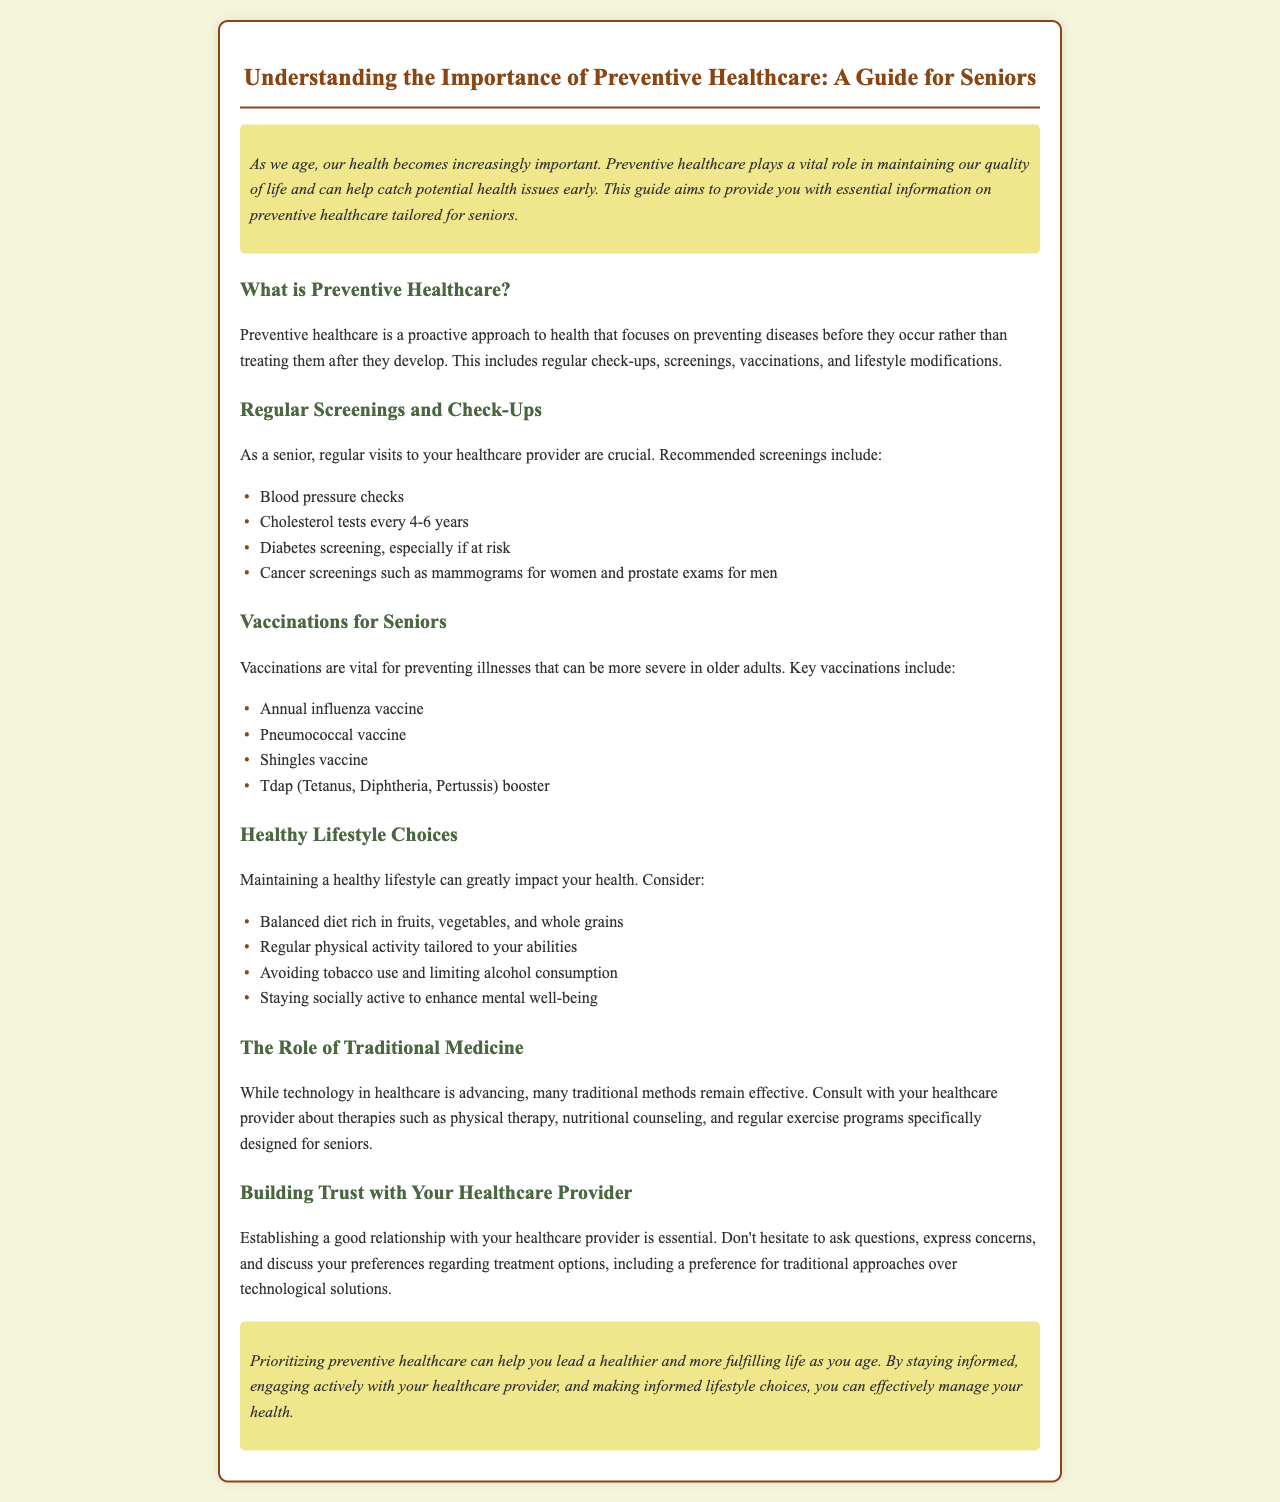What is preventive healthcare? Preventive healthcare is defined in the document as a proactive approach to health that focuses on preventing diseases before they occur.
Answer: A proactive approach to health What are recommended screenings for seniors? The document lists several recommended screenings for seniors, such as blood pressure checks and cholesterol tests.
Answer: Blood pressure checks, cholesterol tests, diabetes screening, cancer screenings What vaccinations are vital for seniors? Key vaccinations for seniors are specified in the document, including the annual influenza vaccine.
Answer: Annual influenza vaccine What is one healthy lifestyle choice mentioned? The document outlines several lifestyle choices, including maintaining a balanced diet rich in fruits and vegetables.
Answer: Balanced diet What should you discuss with your healthcare provider? The document suggests discussing preferences regarding treatment options, emphasizing traditional approaches.
Answer: Treatment options, traditional approaches Why is trust with a healthcare provider important? The document states that trust is essential for establishing a good relationship with your healthcare provider.
Answer: Essential for establishing a good relationship How often should cholesterol tests be performed? The document specifies that cholesterol tests should be done every 4-6 years.
Answer: Every 4-6 years What is one benefit of preventive healthcare mentioned? The conclusion highlights that preventive healthcare can help you lead a healthier and more fulfilling life.
Answer: Healthier and more fulfilling life What should seniors do to enhance mental well-being? The document advises seniors to stay socially active to enhance mental well-being.
Answer: Stay socially active 